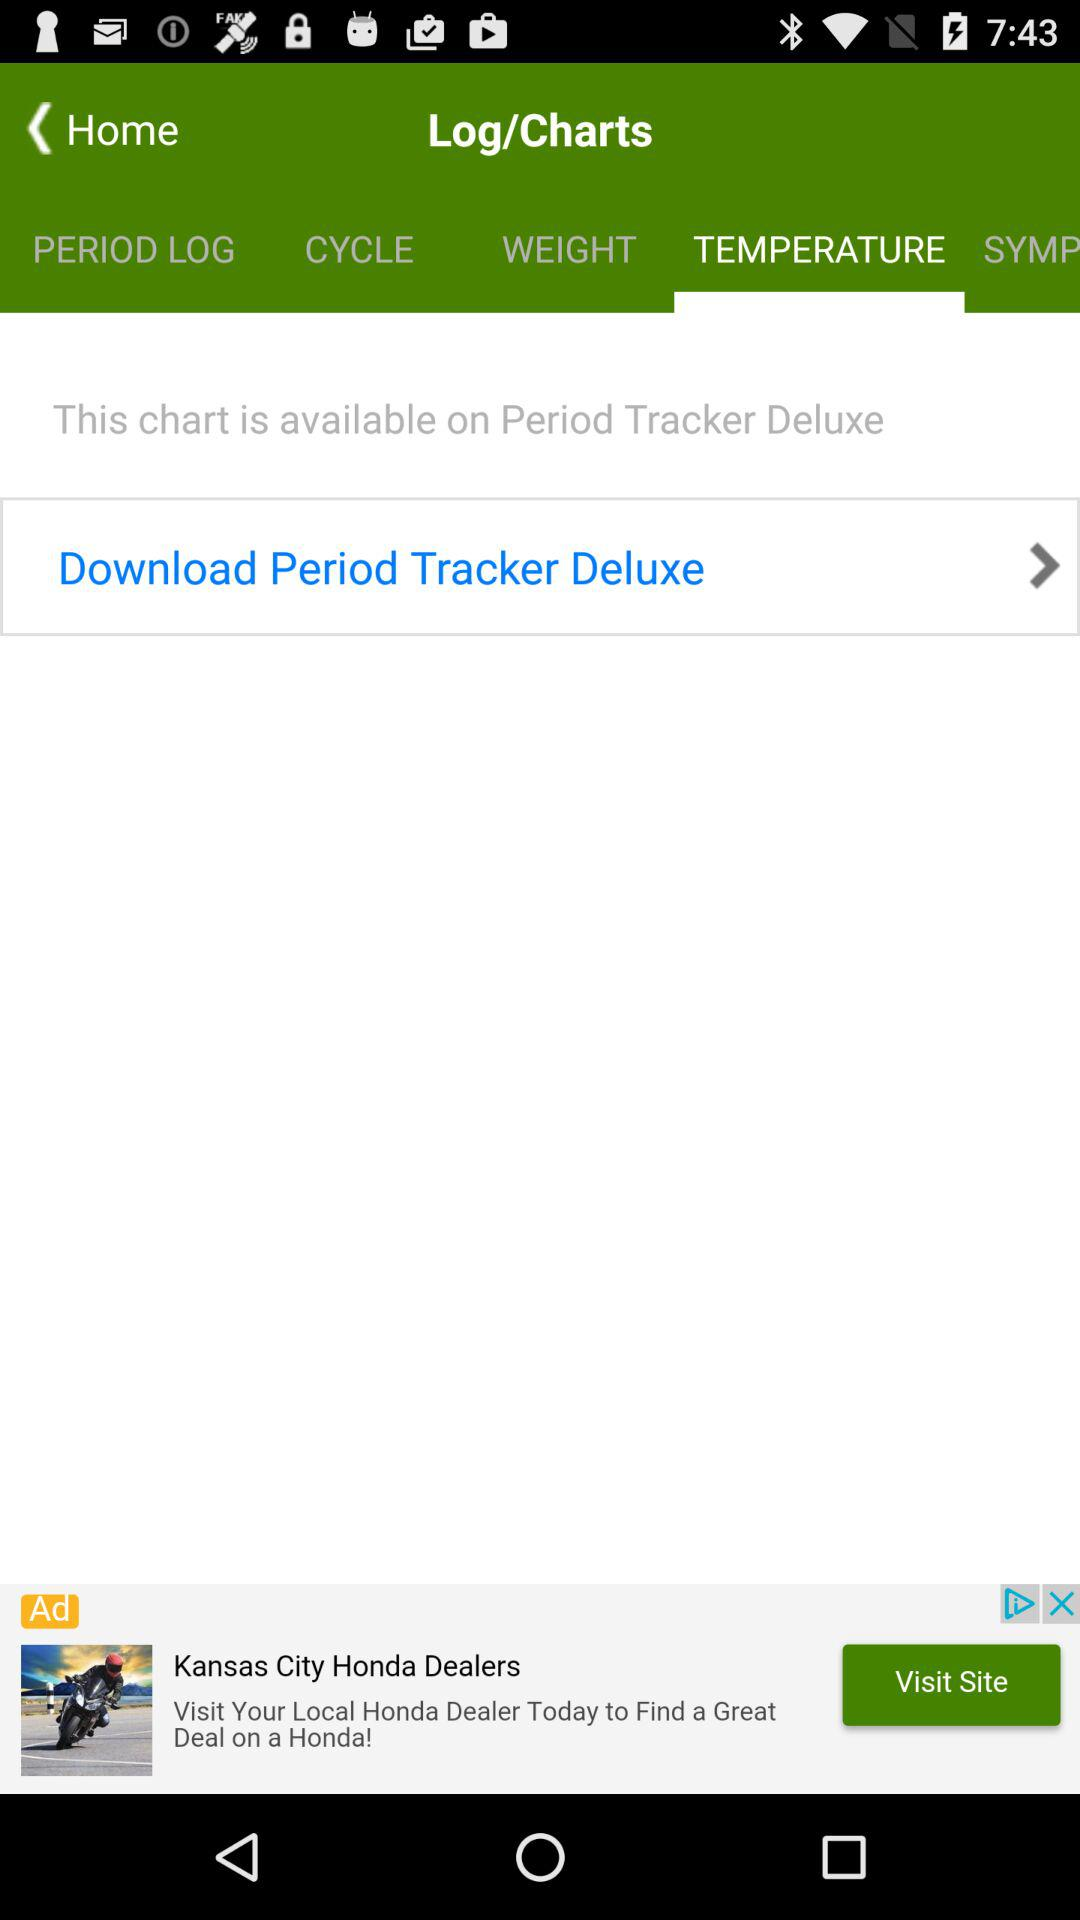What is the name of the application? The name of the application is "Period Tracker Deluxe". 